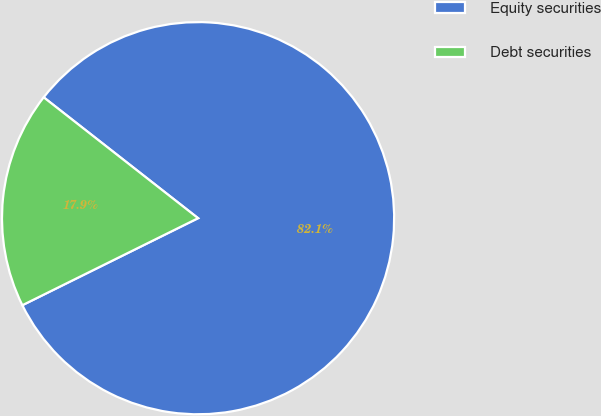Convert chart to OTSL. <chart><loc_0><loc_0><loc_500><loc_500><pie_chart><fcel>Equity securities<fcel>Debt securities<nl><fcel>82.11%<fcel>17.89%<nl></chart> 